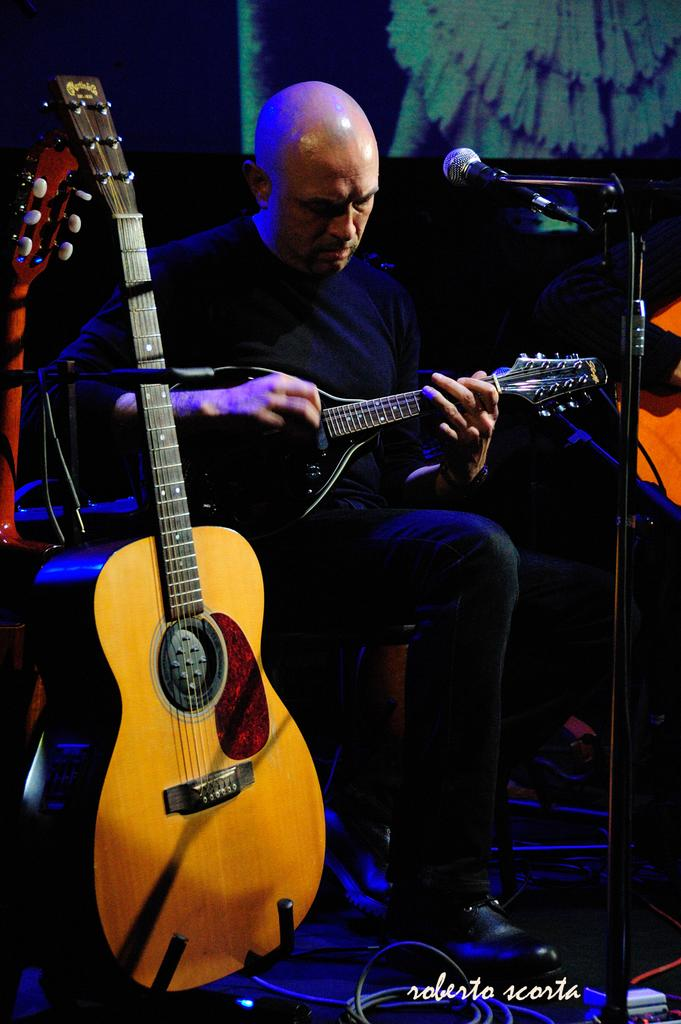What is the main subject of the image? There is a person in the image. What is the person wearing? The person is wearing a black shirt. What is the person doing in the image? The person is sitting and playing a guitar. What object is in front of the person? There is a microphone in front of the person. How many additional guitars are beside the person? There are two additional guitars beside the person. What type of cemetery can be seen in the background of the image? There is no cemetery present in the image; it features a person playing a guitar with a microphone and additional guitars nearby. How many cellars are visible in the image? There are no cellars visible in the image. 